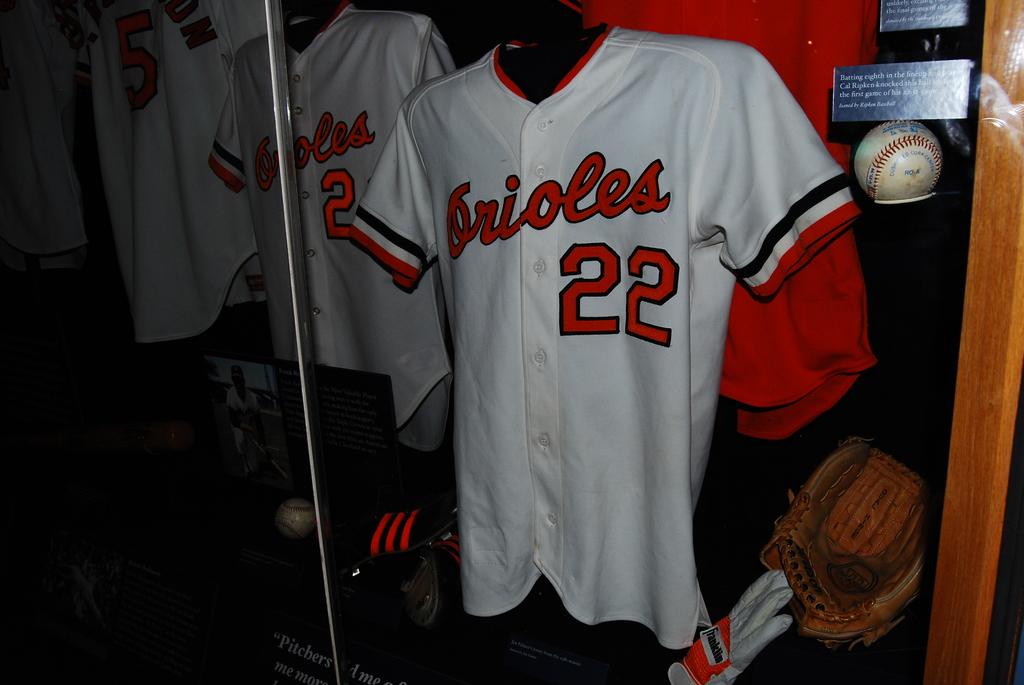What number is on the jersey?
Make the answer very short. 22. What team is this?
Offer a very short reply. Orioles. 